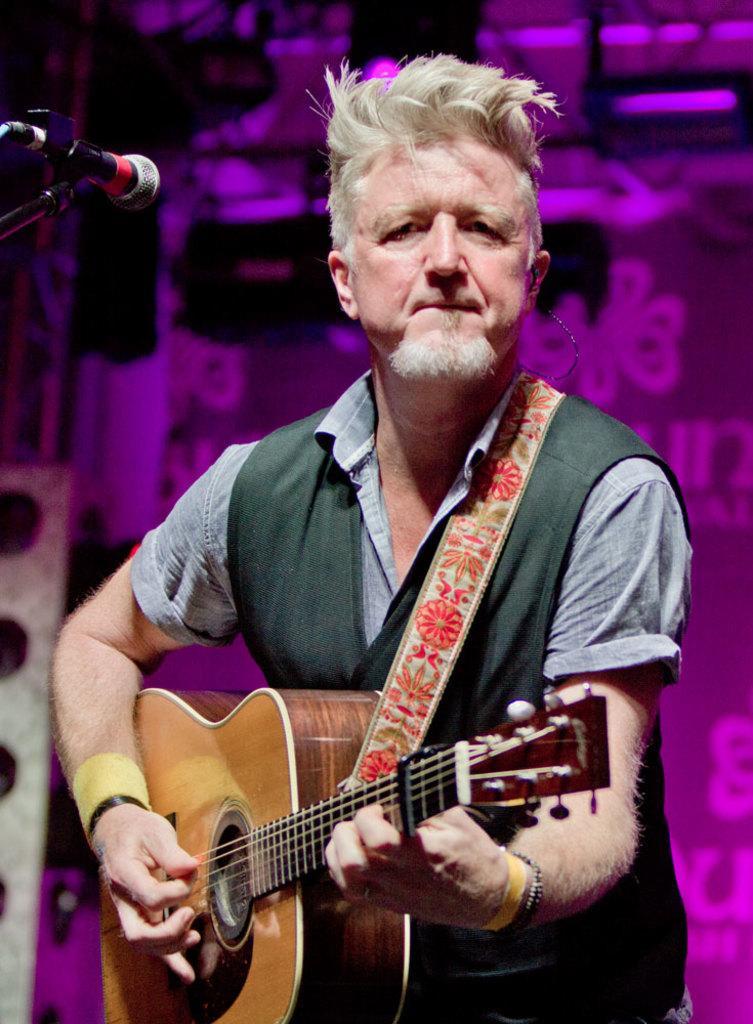Describe this image in one or two sentences. In the center we can see one person holding guitar,on the left we can see microphone. 